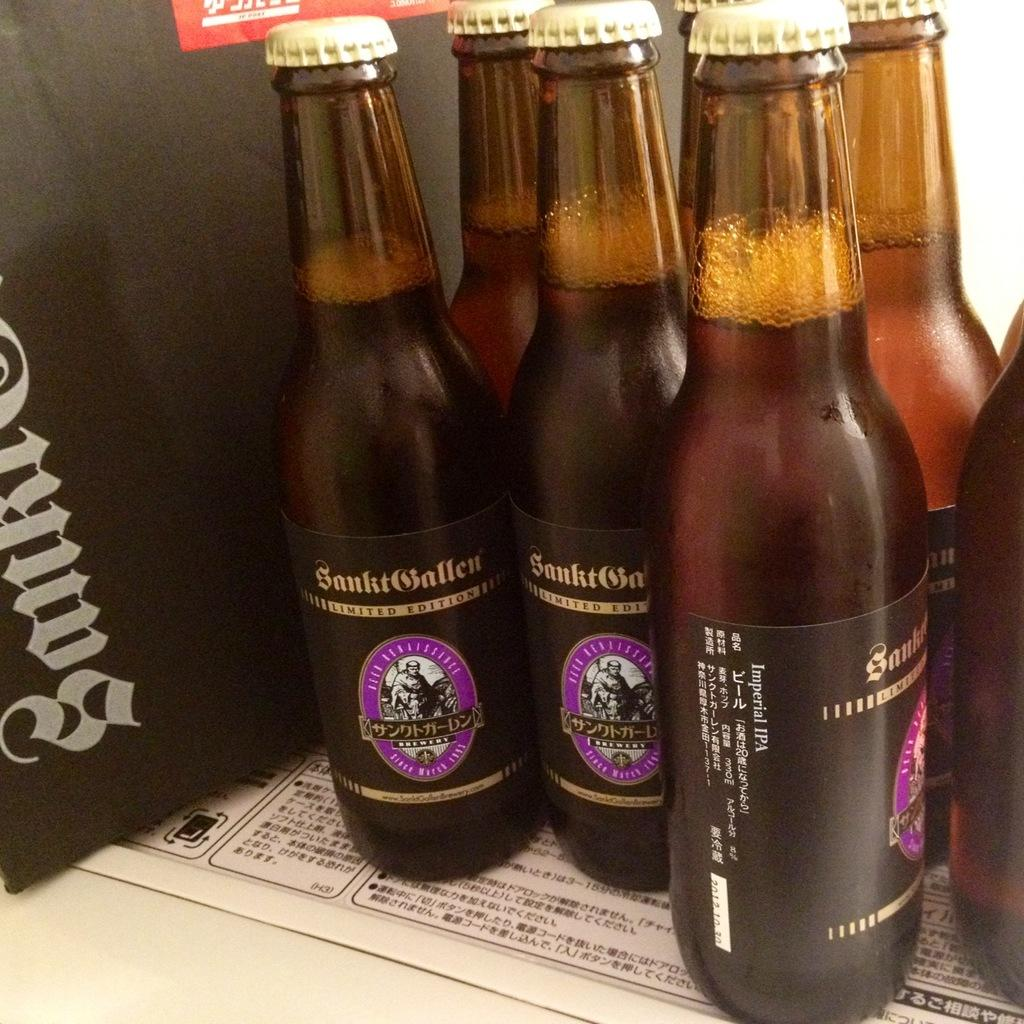Provide a one-sentence caption for the provided image. Three bottles of limited edition beer from a japanese brewery. 